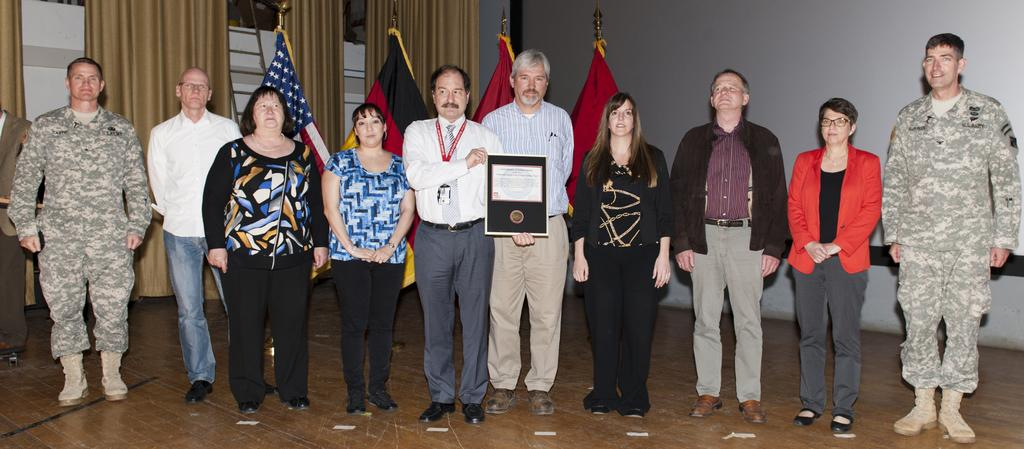How many people are in the image? There are people in the image, but the exact number is not specified. What is the person holding in the image? There is a person holding an object in the image. How many flags can be seen in the background? There are four flags in the background. What type of structure is present in the image? There is a wall in the image. What type of window treatment is visible in the image? There are curtains in the image. What type of bulb is being used to play the instrument in the image? There is no bulb or instrument present in the image. How does the crack in the wall affect the people in the image? There is no crack in the wall mentioned in the image. 